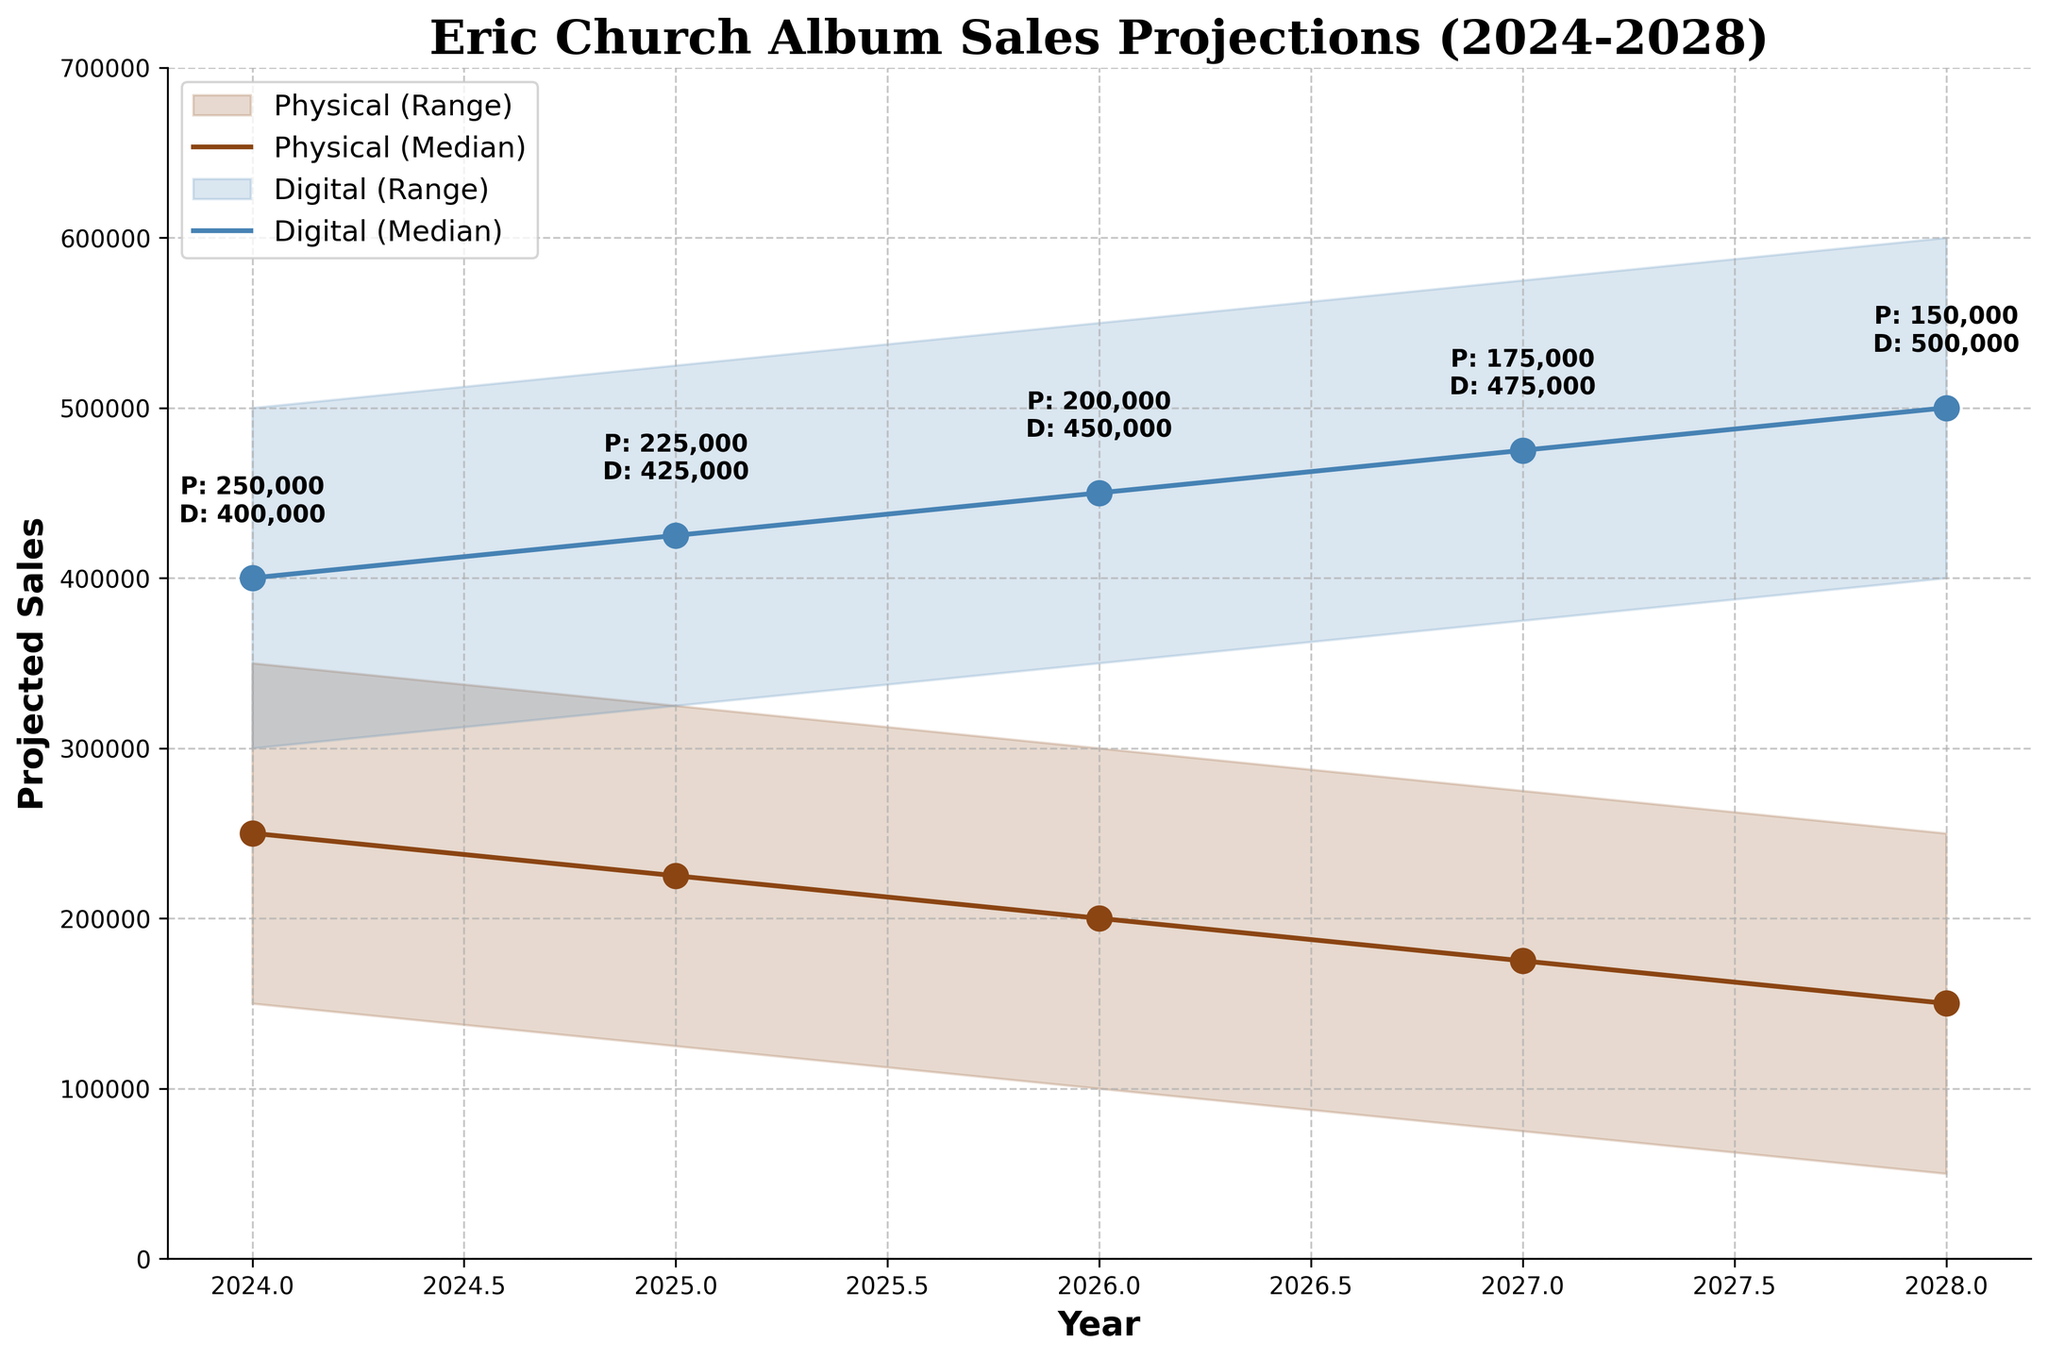What is the title of the figure? The title is directly written at the top of the figure. It describes the content of the chart, which is related to Eric Church album sales projections from 2024 to 2028.
Answer: Eric Church Album Sales Projections (2024-2028) What are the two formats compared in the chart? The chart labels and colors differentiate between the two types of formats. These labels are defined clearly in the legend section of the chart.
Answer: Physical and Digital Which year shows the highest projected median sales for the digital format? First, identify which line represents the digital format from the chart legend. Then follow this line to determine which year has the highest point along the y-axis.
Answer: 2028 What are the projected median sales in 2025 for both physical and digital formats? For 2025, look at the midpoint of the filled areas for both formats and refer to the annotations for exact values.
Answer: Physical: 225,000; Digital: 425,000 How much higher are the median digital sales projected in 2026 compared to median physical sales for the same year? Find the median values for digital and physical formats in 2026 and subtract the physical sales from the digital sales to get the difference.
Answer: 250,000 higher What is the color used to represent the digital format? The chart legend shows the color coding for digital format.
Answer: Light blue By how much do the median physical sales decline from 2024 to 2028? Note the median sales values in 2024 and 2028 for the physical format, then subtract the 2028 value from the 2024 value.
Answer: 100,000 During which years do the median digital sales surpass 500,000? Follow the digital format line and identify which years the median values are above the 500,000 mark.
Answer: 2028 Do the lower bound sales for the physical format ever reach above 150,000 units? Look at the lower bound area for the physical format across all years to check if it ever crosses above the 150,000 mark.
Answer: Yes, in 2024 What are the projected ranges (from Low to High) for the digital format in 2027? Find the range values for the digital format in 2027 by looking at the filled area from the lowest to the highest points.
Answer: 375,000 to 575,000 